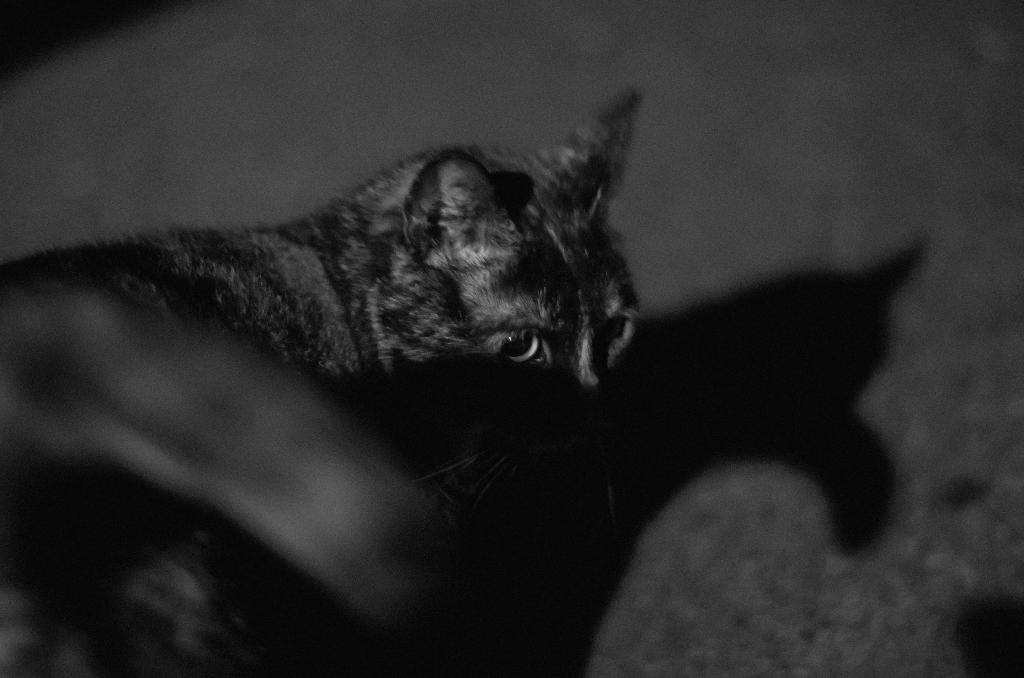What is the color scheme of the image? The image is black and white. What type of animal can be seen in the image? There is a cat in the image. What type of quartz can be seen in the image? There is no quartz present in the image; it features a cat in a black and white setting. Can you see a ghost in the image? There is no ghost present in the image; it features a cat in a black and white setting. 